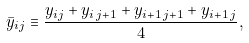<formula> <loc_0><loc_0><loc_500><loc_500>\bar { y } _ { i j } \equiv \frac { y _ { i j } + y _ { i \, j + 1 } + y _ { i + 1 \, j + 1 } + y _ { i + 1 \, j } } 4 ,</formula> 